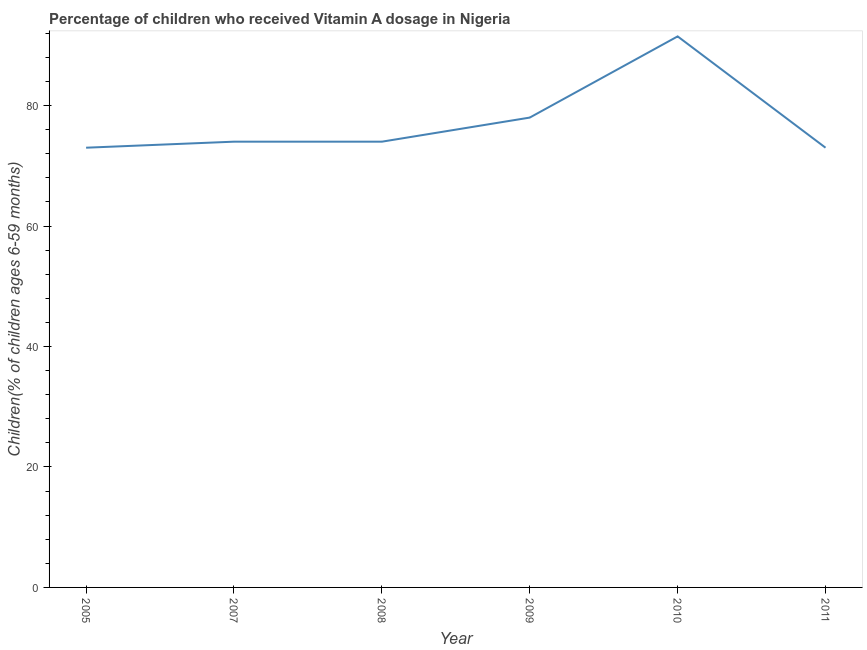Across all years, what is the maximum vitamin a supplementation coverage rate?
Provide a succinct answer. 91.48. Across all years, what is the minimum vitamin a supplementation coverage rate?
Make the answer very short. 73. In which year was the vitamin a supplementation coverage rate maximum?
Offer a very short reply. 2010. In which year was the vitamin a supplementation coverage rate minimum?
Offer a very short reply. 2005. What is the sum of the vitamin a supplementation coverage rate?
Give a very brief answer. 463.48. What is the difference between the vitamin a supplementation coverage rate in 2005 and 2010?
Your answer should be very brief. -18.48. What is the average vitamin a supplementation coverage rate per year?
Make the answer very short. 77.25. What is the ratio of the vitamin a supplementation coverage rate in 2005 to that in 2008?
Provide a short and direct response. 0.99. Is the vitamin a supplementation coverage rate in 2005 less than that in 2010?
Offer a terse response. Yes. Is the difference between the vitamin a supplementation coverage rate in 2005 and 2010 greater than the difference between any two years?
Make the answer very short. Yes. What is the difference between the highest and the second highest vitamin a supplementation coverage rate?
Make the answer very short. 13.48. Is the sum of the vitamin a supplementation coverage rate in 2005 and 2009 greater than the maximum vitamin a supplementation coverage rate across all years?
Your answer should be very brief. Yes. What is the difference between the highest and the lowest vitamin a supplementation coverage rate?
Make the answer very short. 18.48. In how many years, is the vitamin a supplementation coverage rate greater than the average vitamin a supplementation coverage rate taken over all years?
Provide a succinct answer. 2. What is the difference between two consecutive major ticks on the Y-axis?
Keep it short and to the point. 20. What is the title of the graph?
Offer a terse response. Percentage of children who received Vitamin A dosage in Nigeria. What is the label or title of the Y-axis?
Offer a terse response. Children(% of children ages 6-59 months). What is the Children(% of children ages 6-59 months) in 2005?
Offer a terse response. 73. What is the Children(% of children ages 6-59 months) of 2008?
Offer a very short reply. 74. What is the Children(% of children ages 6-59 months) of 2009?
Ensure brevity in your answer.  78. What is the Children(% of children ages 6-59 months) in 2010?
Your answer should be compact. 91.48. What is the Children(% of children ages 6-59 months) in 2011?
Your answer should be very brief. 73. What is the difference between the Children(% of children ages 6-59 months) in 2005 and 2010?
Make the answer very short. -18.48. What is the difference between the Children(% of children ages 6-59 months) in 2005 and 2011?
Provide a succinct answer. 0. What is the difference between the Children(% of children ages 6-59 months) in 2007 and 2010?
Provide a short and direct response. -17.48. What is the difference between the Children(% of children ages 6-59 months) in 2007 and 2011?
Your answer should be compact. 1. What is the difference between the Children(% of children ages 6-59 months) in 2008 and 2010?
Make the answer very short. -17.48. What is the difference between the Children(% of children ages 6-59 months) in 2009 and 2010?
Your answer should be compact. -13.48. What is the difference between the Children(% of children ages 6-59 months) in 2010 and 2011?
Your answer should be very brief. 18.48. What is the ratio of the Children(% of children ages 6-59 months) in 2005 to that in 2009?
Offer a terse response. 0.94. What is the ratio of the Children(% of children ages 6-59 months) in 2005 to that in 2010?
Give a very brief answer. 0.8. What is the ratio of the Children(% of children ages 6-59 months) in 2005 to that in 2011?
Your answer should be very brief. 1. What is the ratio of the Children(% of children ages 6-59 months) in 2007 to that in 2008?
Your answer should be very brief. 1. What is the ratio of the Children(% of children ages 6-59 months) in 2007 to that in 2009?
Provide a succinct answer. 0.95. What is the ratio of the Children(% of children ages 6-59 months) in 2007 to that in 2010?
Make the answer very short. 0.81. What is the ratio of the Children(% of children ages 6-59 months) in 2008 to that in 2009?
Ensure brevity in your answer.  0.95. What is the ratio of the Children(% of children ages 6-59 months) in 2008 to that in 2010?
Your answer should be very brief. 0.81. What is the ratio of the Children(% of children ages 6-59 months) in 2009 to that in 2010?
Offer a very short reply. 0.85. What is the ratio of the Children(% of children ages 6-59 months) in 2009 to that in 2011?
Provide a succinct answer. 1.07. What is the ratio of the Children(% of children ages 6-59 months) in 2010 to that in 2011?
Your answer should be very brief. 1.25. 